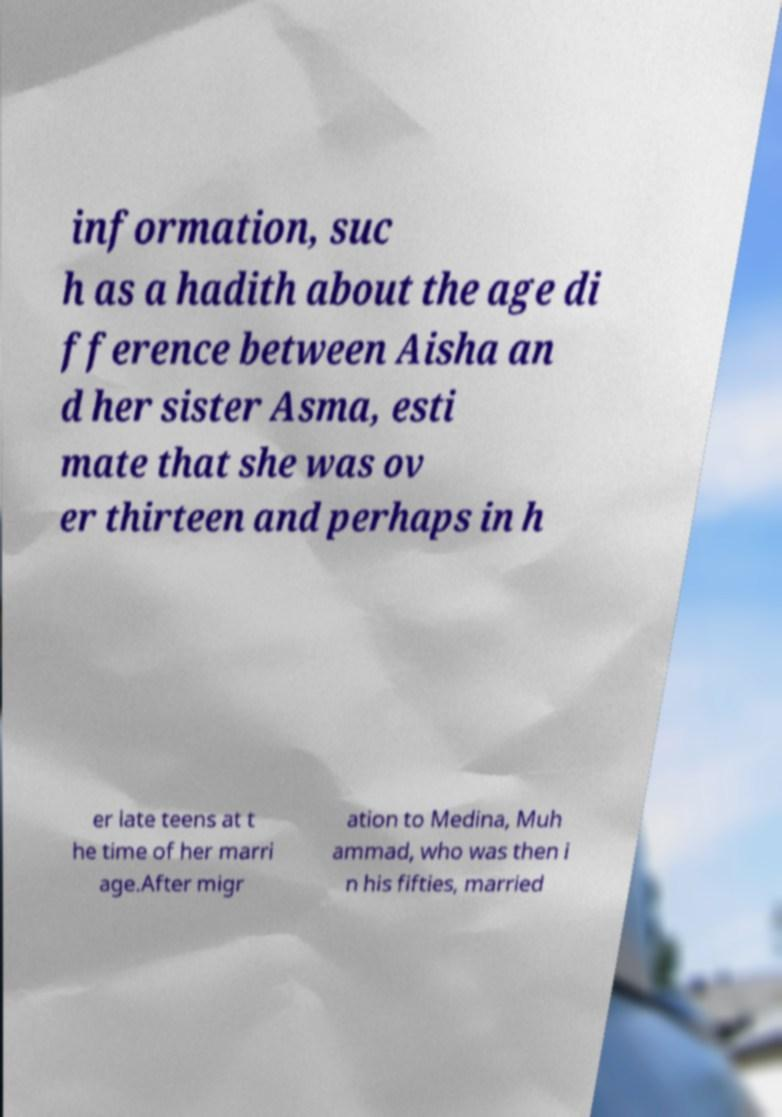For documentation purposes, I need the text within this image transcribed. Could you provide that? information, suc h as a hadith about the age di fference between Aisha an d her sister Asma, esti mate that she was ov er thirteen and perhaps in h er late teens at t he time of her marri age.After migr ation to Medina, Muh ammad, who was then i n his fifties, married 